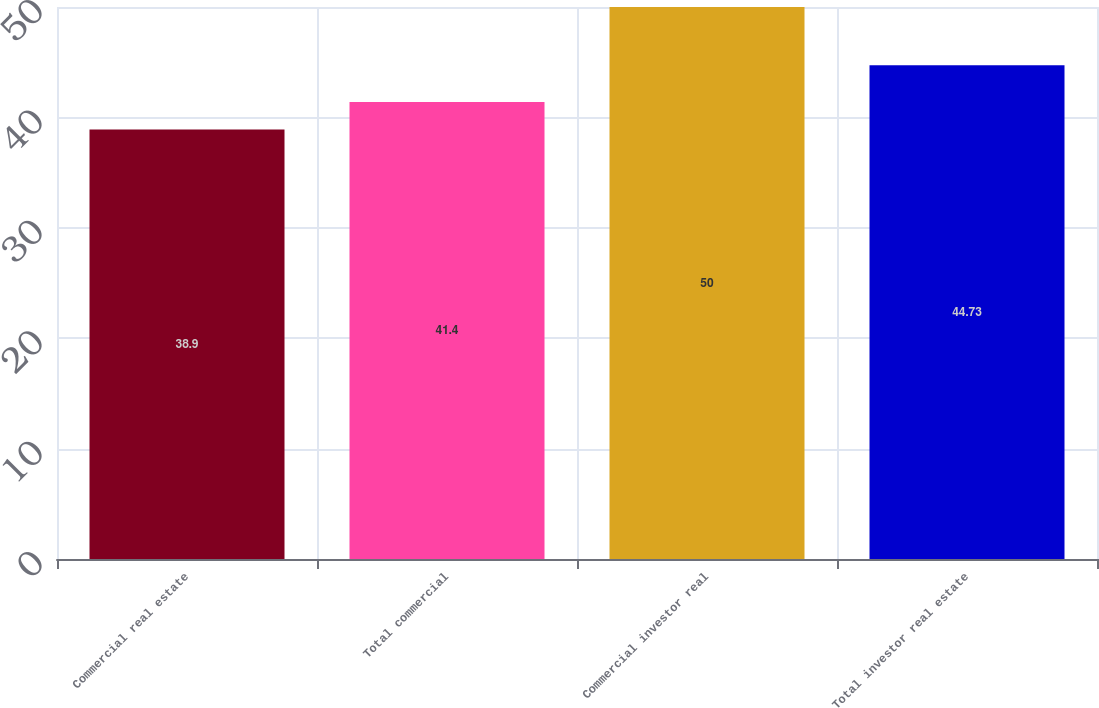<chart> <loc_0><loc_0><loc_500><loc_500><bar_chart><fcel>Commercial real estate<fcel>Total commercial<fcel>Commercial investor real<fcel>Total investor real estate<nl><fcel>38.9<fcel>41.4<fcel>50<fcel>44.73<nl></chart> 